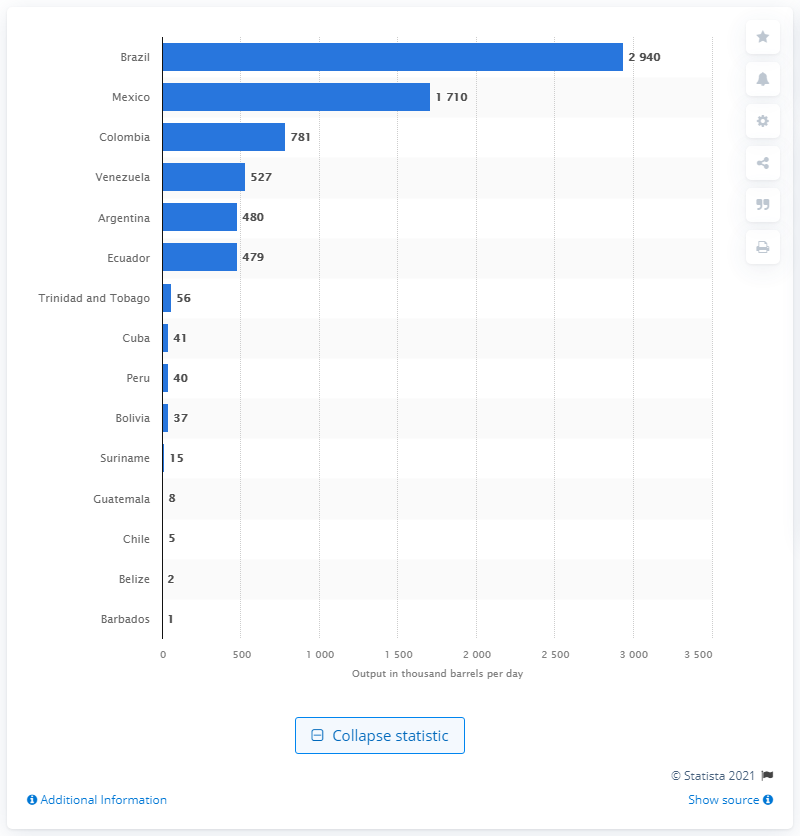Give some essential details in this illustration. In 2020, Mexico was the country that produced the most daily barrels of crude oil. In 2020, Brazil was the largest crude oil producing country in Latin America and the Caribbean. 